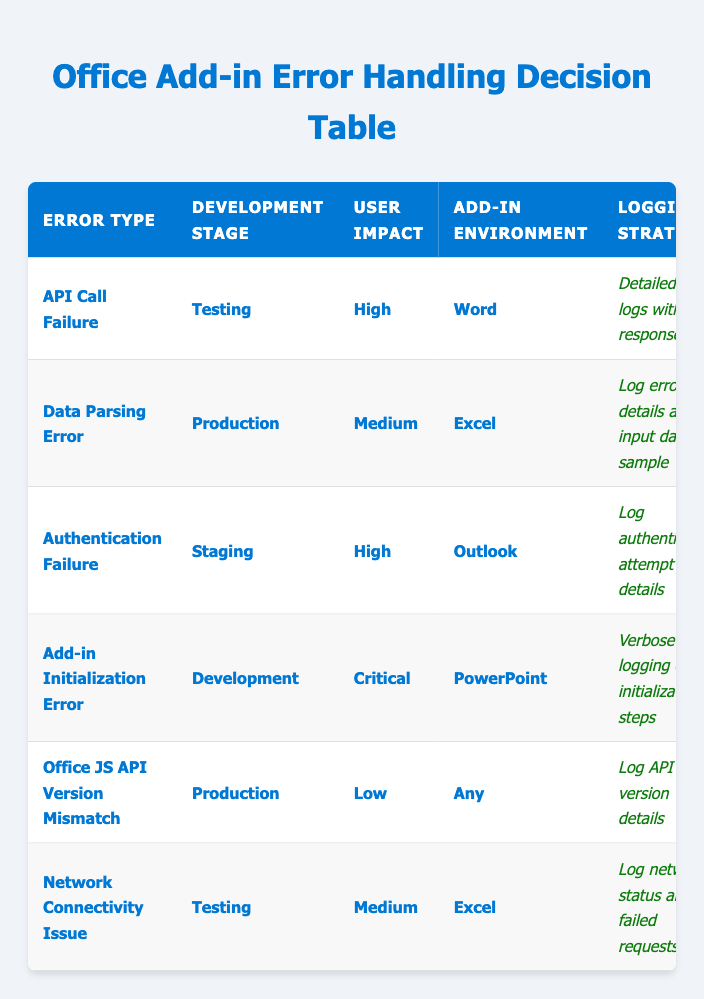What is the logging strategy for an API call failure in the testing stage? From the table, the logging strategy for an API call failure during the testing stage is "Detailed error logs with API response."
Answer: Detailed error logs with API response How many error types have a high user impact? By reviewing the table, we see that there are three error types (API Call Failure, Authentication Failure, and Add-in Initialization Error) that are marked as having a high user impact.
Answer: Three Is there a retry mechanism for the network connectivity issue? According to the table, the network connectivity issue has a retry mechanism that involves "Implement request queue for retry." Therefore, it is true that there is a retry mechanism.
Answer: Yes What is the fallback behavior for data parsing errors? Looking at the table, the fallback behavior for data parsing errors is "Skip problematic data entry."
Answer: Skip problematic data entry For which error type is the user notified to display technical error details for debugging? The table shows that the error type of "Add-in Initialization Error" prompts the user to display technical error details for debugging.
Answer: Add-in Initialization Error How do the logging strategies differ between the authentication failure in the staging stage and the office JS API version mismatch in production? From the table, the logging strategy for authentication failure is "Log authentication attempt details," whereas for the office JS API version mismatch, it is "Log API version details." Thus, the strategies differ in focus—one logs authentication attempts and the other logs API version information.
Answer: They differ What is the user impact for the add-in initialization error? The user impact for the add-in initialization error is classified as "Critical" according to the table.
Answer: Critical Which error types have a fallback behavior of using cached data if available? The table indicates that the fallback behavior of using cached data if available is specific to "API Call Failure."
Answer: API Call Failure 